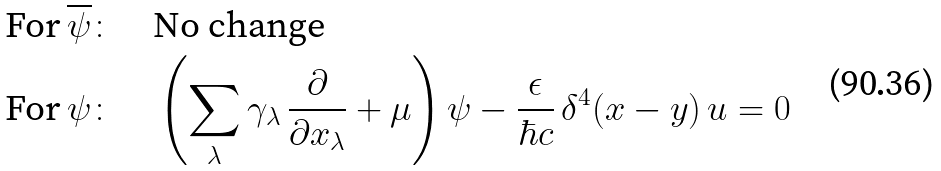<formula> <loc_0><loc_0><loc_500><loc_500>\text {For} \, \overline { \psi } & \colon \quad \text {No change} \\ \text {For} \, \psi & \colon \quad \left ( \sum _ { \lambda } \gamma _ { \lambda } \, \frac { \partial } { \partial x _ { \lambda } } + \mu \right ) \psi - \frac { \epsilon } { \hbar { c } } \, \delta ^ { 4 } ( x - y ) \, u = 0</formula> 